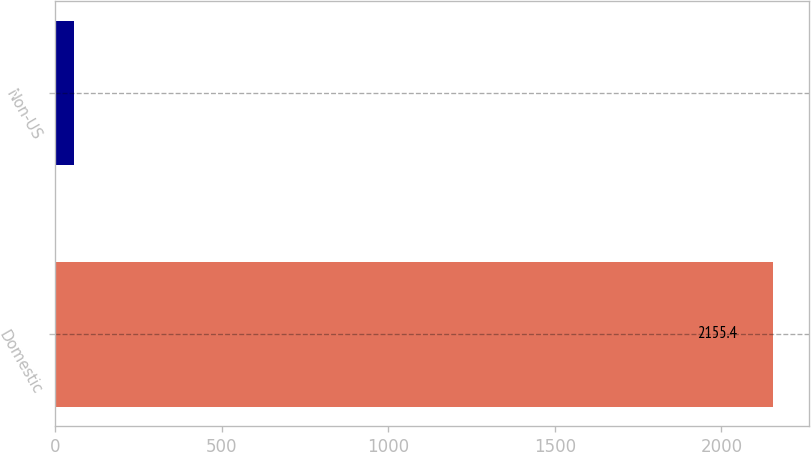Convert chart. <chart><loc_0><loc_0><loc_500><loc_500><bar_chart><fcel>Domestic<fcel>Non-US<nl><fcel>2155.4<fcel>54.3<nl></chart> 